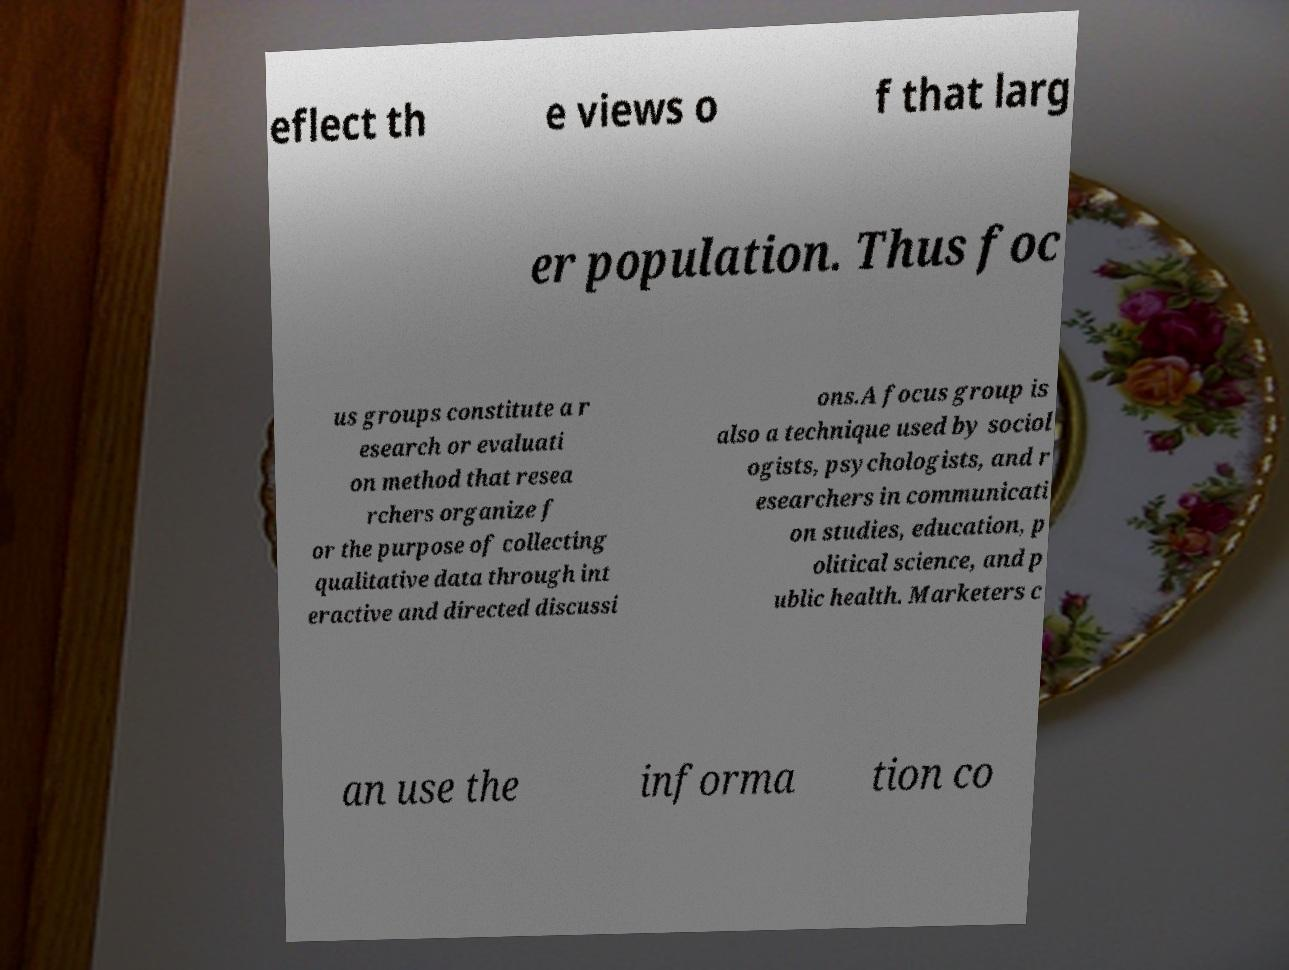Can you accurately transcribe the text from the provided image for me? eflect th e views o f that larg er population. Thus foc us groups constitute a r esearch or evaluati on method that resea rchers organize f or the purpose of collecting qualitative data through int eractive and directed discussi ons.A focus group is also a technique used by sociol ogists, psychologists, and r esearchers in communicati on studies, education, p olitical science, and p ublic health. Marketers c an use the informa tion co 